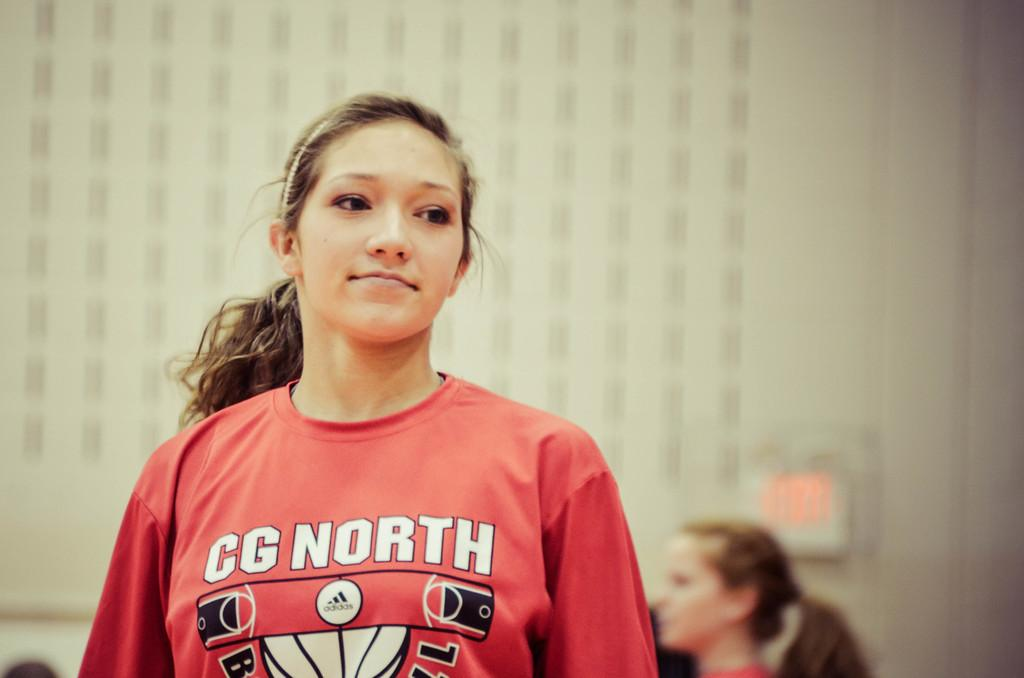<image>
Provide a brief description of the given image. a girl with a CG North jersey on 